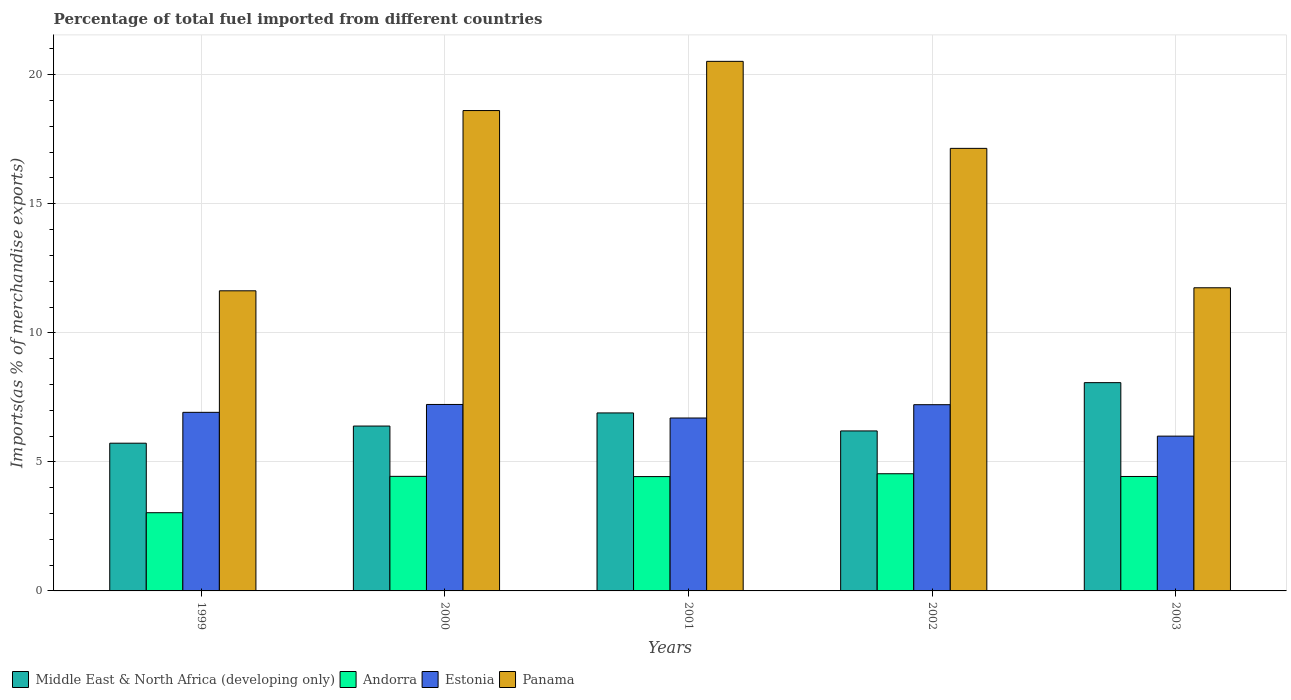How many groups of bars are there?
Your answer should be compact. 5. How many bars are there on the 4th tick from the left?
Make the answer very short. 4. How many bars are there on the 4th tick from the right?
Your answer should be very brief. 4. What is the label of the 4th group of bars from the left?
Keep it short and to the point. 2002. What is the percentage of imports to different countries in Estonia in 1999?
Your answer should be compact. 6.92. Across all years, what is the maximum percentage of imports to different countries in Panama?
Make the answer very short. 20.52. Across all years, what is the minimum percentage of imports to different countries in Estonia?
Make the answer very short. 6. In which year was the percentage of imports to different countries in Middle East & North Africa (developing only) maximum?
Keep it short and to the point. 2003. What is the total percentage of imports to different countries in Estonia in the graph?
Give a very brief answer. 34.06. What is the difference between the percentage of imports to different countries in Middle East & North Africa (developing only) in 1999 and that in 2000?
Provide a succinct answer. -0.66. What is the difference between the percentage of imports to different countries in Panama in 2001 and the percentage of imports to different countries in Estonia in 1999?
Ensure brevity in your answer.  13.6. What is the average percentage of imports to different countries in Panama per year?
Your answer should be very brief. 15.93. In the year 2001, what is the difference between the percentage of imports to different countries in Andorra and percentage of imports to different countries in Estonia?
Ensure brevity in your answer.  -2.27. What is the ratio of the percentage of imports to different countries in Andorra in 1999 to that in 2000?
Give a very brief answer. 0.68. Is the percentage of imports to different countries in Estonia in 2000 less than that in 2002?
Offer a terse response. No. Is the difference between the percentage of imports to different countries in Andorra in 1999 and 2000 greater than the difference between the percentage of imports to different countries in Estonia in 1999 and 2000?
Your answer should be compact. No. What is the difference between the highest and the second highest percentage of imports to different countries in Middle East & North Africa (developing only)?
Your answer should be very brief. 1.17. What is the difference between the highest and the lowest percentage of imports to different countries in Estonia?
Give a very brief answer. 1.23. In how many years, is the percentage of imports to different countries in Middle East & North Africa (developing only) greater than the average percentage of imports to different countries in Middle East & North Africa (developing only) taken over all years?
Your response must be concise. 2. Is the sum of the percentage of imports to different countries in Panama in 1999 and 2000 greater than the maximum percentage of imports to different countries in Andorra across all years?
Keep it short and to the point. Yes. What does the 2nd bar from the left in 2003 represents?
Give a very brief answer. Andorra. What does the 3rd bar from the right in 1999 represents?
Make the answer very short. Andorra. Is it the case that in every year, the sum of the percentage of imports to different countries in Middle East & North Africa (developing only) and percentage of imports to different countries in Andorra is greater than the percentage of imports to different countries in Estonia?
Offer a terse response. Yes. What is the difference between two consecutive major ticks on the Y-axis?
Provide a succinct answer. 5. Where does the legend appear in the graph?
Give a very brief answer. Bottom left. What is the title of the graph?
Your answer should be very brief. Percentage of total fuel imported from different countries. Does "Solomon Islands" appear as one of the legend labels in the graph?
Your answer should be compact. No. What is the label or title of the X-axis?
Provide a short and direct response. Years. What is the label or title of the Y-axis?
Provide a short and direct response. Imports(as % of merchandise exports). What is the Imports(as % of merchandise exports) of Middle East & North Africa (developing only) in 1999?
Give a very brief answer. 5.72. What is the Imports(as % of merchandise exports) of Andorra in 1999?
Provide a short and direct response. 3.03. What is the Imports(as % of merchandise exports) of Estonia in 1999?
Your answer should be compact. 6.92. What is the Imports(as % of merchandise exports) of Panama in 1999?
Your answer should be compact. 11.63. What is the Imports(as % of merchandise exports) of Middle East & North Africa (developing only) in 2000?
Provide a short and direct response. 6.39. What is the Imports(as % of merchandise exports) in Andorra in 2000?
Your response must be concise. 4.44. What is the Imports(as % of merchandise exports) of Estonia in 2000?
Provide a succinct answer. 7.22. What is the Imports(as % of merchandise exports) of Panama in 2000?
Offer a very short reply. 18.61. What is the Imports(as % of merchandise exports) in Middle East & North Africa (developing only) in 2001?
Offer a very short reply. 6.9. What is the Imports(as % of merchandise exports) of Andorra in 2001?
Your response must be concise. 4.43. What is the Imports(as % of merchandise exports) in Estonia in 2001?
Your answer should be very brief. 6.7. What is the Imports(as % of merchandise exports) in Panama in 2001?
Offer a very short reply. 20.52. What is the Imports(as % of merchandise exports) in Middle East & North Africa (developing only) in 2002?
Your answer should be very brief. 6.2. What is the Imports(as % of merchandise exports) of Andorra in 2002?
Your answer should be very brief. 4.54. What is the Imports(as % of merchandise exports) in Estonia in 2002?
Your response must be concise. 7.22. What is the Imports(as % of merchandise exports) of Panama in 2002?
Keep it short and to the point. 17.15. What is the Imports(as % of merchandise exports) in Middle East & North Africa (developing only) in 2003?
Give a very brief answer. 8.07. What is the Imports(as % of merchandise exports) of Andorra in 2003?
Your response must be concise. 4.43. What is the Imports(as % of merchandise exports) in Estonia in 2003?
Keep it short and to the point. 6. What is the Imports(as % of merchandise exports) of Panama in 2003?
Make the answer very short. 11.75. Across all years, what is the maximum Imports(as % of merchandise exports) of Middle East & North Africa (developing only)?
Offer a very short reply. 8.07. Across all years, what is the maximum Imports(as % of merchandise exports) of Andorra?
Keep it short and to the point. 4.54. Across all years, what is the maximum Imports(as % of merchandise exports) in Estonia?
Give a very brief answer. 7.22. Across all years, what is the maximum Imports(as % of merchandise exports) in Panama?
Make the answer very short. 20.52. Across all years, what is the minimum Imports(as % of merchandise exports) of Middle East & North Africa (developing only)?
Your answer should be compact. 5.72. Across all years, what is the minimum Imports(as % of merchandise exports) of Andorra?
Your response must be concise. 3.03. Across all years, what is the minimum Imports(as % of merchandise exports) of Estonia?
Provide a succinct answer. 6. Across all years, what is the minimum Imports(as % of merchandise exports) in Panama?
Ensure brevity in your answer.  11.63. What is the total Imports(as % of merchandise exports) in Middle East & North Africa (developing only) in the graph?
Keep it short and to the point. 33.28. What is the total Imports(as % of merchandise exports) of Andorra in the graph?
Give a very brief answer. 20.87. What is the total Imports(as % of merchandise exports) in Estonia in the graph?
Keep it short and to the point. 34.06. What is the total Imports(as % of merchandise exports) of Panama in the graph?
Provide a short and direct response. 79.65. What is the difference between the Imports(as % of merchandise exports) of Middle East & North Africa (developing only) in 1999 and that in 2000?
Give a very brief answer. -0.66. What is the difference between the Imports(as % of merchandise exports) of Andorra in 1999 and that in 2000?
Your answer should be very brief. -1.41. What is the difference between the Imports(as % of merchandise exports) in Estonia in 1999 and that in 2000?
Your answer should be very brief. -0.3. What is the difference between the Imports(as % of merchandise exports) of Panama in 1999 and that in 2000?
Your answer should be very brief. -6.98. What is the difference between the Imports(as % of merchandise exports) of Middle East & North Africa (developing only) in 1999 and that in 2001?
Offer a very short reply. -1.17. What is the difference between the Imports(as % of merchandise exports) of Andorra in 1999 and that in 2001?
Your answer should be compact. -1.4. What is the difference between the Imports(as % of merchandise exports) of Estonia in 1999 and that in 2001?
Keep it short and to the point. 0.22. What is the difference between the Imports(as % of merchandise exports) of Panama in 1999 and that in 2001?
Your answer should be compact. -8.89. What is the difference between the Imports(as % of merchandise exports) in Middle East & North Africa (developing only) in 1999 and that in 2002?
Ensure brevity in your answer.  -0.48. What is the difference between the Imports(as % of merchandise exports) in Andorra in 1999 and that in 2002?
Give a very brief answer. -1.51. What is the difference between the Imports(as % of merchandise exports) of Estonia in 1999 and that in 2002?
Make the answer very short. -0.3. What is the difference between the Imports(as % of merchandise exports) in Panama in 1999 and that in 2002?
Make the answer very short. -5.52. What is the difference between the Imports(as % of merchandise exports) of Middle East & North Africa (developing only) in 1999 and that in 2003?
Your answer should be compact. -2.35. What is the difference between the Imports(as % of merchandise exports) in Andorra in 1999 and that in 2003?
Keep it short and to the point. -1.4. What is the difference between the Imports(as % of merchandise exports) in Estonia in 1999 and that in 2003?
Give a very brief answer. 0.92. What is the difference between the Imports(as % of merchandise exports) of Panama in 1999 and that in 2003?
Offer a very short reply. -0.12. What is the difference between the Imports(as % of merchandise exports) of Middle East & North Africa (developing only) in 2000 and that in 2001?
Provide a succinct answer. -0.51. What is the difference between the Imports(as % of merchandise exports) in Andorra in 2000 and that in 2001?
Keep it short and to the point. 0.01. What is the difference between the Imports(as % of merchandise exports) in Estonia in 2000 and that in 2001?
Give a very brief answer. 0.52. What is the difference between the Imports(as % of merchandise exports) in Panama in 2000 and that in 2001?
Give a very brief answer. -1.91. What is the difference between the Imports(as % of merchandise exports) of Middle East & North Africa (developing only) in 2000 and that in 2002?
Make the answer very short. 0.19. What is the difference between the Imports(as % of merchandise exports) in Andorra in 2000 and that in 2002?
Provide a short and direct response. -0.1. What is the difference between the Imports(as % of merchandise exports) in Estonia in 2000 and that in 2002?
Give a very brief answer. 0.01. What is the difference between the Imports(as % of merchandise exports) in Panama in 2000 and that in 2002?
Keep it short and to the point. 1.46. What is the difference between the Imports(as % of merchandise exports) in Middle East & North Africa (developing only) in 2000 and that in 2003?
Make the answer very short. -1.68. What is the difference between the Imports(as % of merchandise exports) in Andorra in 2000 and that in 2003?
Provide a succinct answer. 0. What is the difference between the Imports(as % of merchandise exports) of Estonia in 2000 and that in 2003?
Your answer should be compact. 1.23. What is the difference between the Imports(as % of merchandise exports) of Panama in 2000 and that in 2003?
Provide a succinct answer. 6.87. What is the difference between the Imports(as % of merchandise exports) of Middle East & North Africa (developing only) in 2001 and that in 2002?
Your answer should be very brief. 0.7. What is the difference between the Imports(as % of merchandise exports) in Andorra in 2001 and that in 2002?
Your answer should be very brief. -0.11. What is the difference between the Imports(as % of merchandise exports) of Estonia in 2001 and that in 2002?
Give a very brief answer. -0.52. What is the difference between the Imports(as % of merchandise exports) of Panama in 2001 and that in 2002?
Your answer should be compact. 3.37. What is the difference between the Imports(as % of merchandise exports) of Middle East & North Africa (developing only) in 2001 and that in 2003?
Your answer should be very brief. -1.17. What is the difference between the Imports(as % of merchandise exports) of Andorra in 2001 and that in 2003?
Provide a short and direct response. -0. What is the difference between the Imports(as % of merchandise exports) of Estonia in 2001 and that in 2003?
Provide a succinct answer. 0.7. What is the difference between the Imports(as % of merchandise exports) of Panama in 2001 and that in 2003?
Keep it short and to the point. 8.77. What is the difference between the Imports(as % of merchandise exports) of Middle East & North Africa (developing only) in 2002 and that in 2003?
Provide a short and direct response. -1.87. What is the difference between the Imports(as % of merchandise exports) in Andorra in 2002 and that in 2003?
Your answer should be compact. 0.11. What is the difference between the Imports(as % of merchandise exports) of Estonia in 2002 and that in 2003?
Your response must be concise. 1.22. What is the difference between the Imports(as % of merchandise exports) in Panama in 2002 and that in 2003?
Provide a short and direct response. 5.4. What is the difference between the Imports(as % of merchandise exports) of Middle East & North Africa (developing only) in 1999 and the Imports(as % of merchandise exports) of Andorra in 2000?
Your response must be concise. 1.28. What is the difference between the Imports(as % of merchandise exports) in Middle East & North Africa (developing only) in 1999 and the Imports(as % of merchandise exports) in Estonia in 2000?
Your response must be concise. -1.5. What is the difference between the Imports(as % of merchandise exports) of Middle East & North Africa (developing only) in 1999 and the Imports(as % of merchandise exports) of Panama in 2000?
Make the answer very short. -12.89. What is the difference between the Imports(as % of merchandise exports) in Andorra in 1999 and the Imports(as % of merchandise exports) in Estonia in 2000?
Give a very brief answer. -4.19. What is the difference between the Imports(as % of merchandise exports) of Andorra in 1999 and the Imports(as % of merchandise exports) of Panama in 2000?
Provide a succinct answer. -15.58. What is the difference between the Imports(as % of merchandise exports) in Estonia in 1999 and the Imports(as % of merchandise exports) in Panama in 2000?
Your response must be concise. -11.69. What is the difference between the Imports(as % of merchandise exports) of Middle East & North Africa (developing only) in 1999 and the Imports(as % of merchandise exports) of Andorra in 2001?
Ensure brevity in your answer.  1.29. What is the difference between the Imports(as % of merchandise exports) in Middle East & North Africa (developing only) in 1999 and the Imports(as % of merchandise exports) in Estonia in 2001?
Provide a short and direct response. -0.98. What is the difference between the Imports(as % of merchandise exports) in Middle East & North Africa (developing only) in 1999 and the Imports(as % of merchandise exports) in Panama in 2001?
Make the answer very short. -14.79. What is the difference between the Imports(as % of merchandise exports) in Andorra in 1999 and the Imports(as % of merchandise exports) in Estonia in 2001?
Your answer should be very brief. -3.67. What is the difference between the Imports(as % of merchandise exports) in Andorra in 1999 and the Imports(as % of merchandise exports) in Panama in 2001?
Give a very brief answer. -17.49. What is the difference between the Imports(as % of merchandise exports) in Estonia in 1999 and the Imports(as % of merchandise exports) in Panama in 2001?
Ensure brevity in your answer.  -13.6. What is the difference between the Imports(as % of merchandise exports) in Middle East & North Africa (developing only) in 1999 and the Imports(as % of merchandise exports) in Andorra in 2002?
Offer a very short reply. 1.18. What is the difference between the Imports(as % of merchandise exports) in Middle East & North Africa (developing only) in 1999 and the Imports(as % of merchandise exports) in Estonia in 2002?
Make the answer very short. -1.49. What is the difference between the Imports(as % of merchandise exports) of Middle East & North Africa (developing only) in 1999 and the Imports(as % of merchandise exports) of Panama in 2002?
Offer a very short reply. -11.42. What is the difference between the Imports(as % of merchandise exports) of Andorra in 1999 and the Imports(as % of merchandise exports) of Estonia in 2002?
Offer a very short reply. -4.18. What is the difference between the Imports(as % of merchandise exports) in Andorra in 1999 and the Imports(as % of merchandise exports) in Panama in 2002?
Give a very brief answer. -14.12. What is the difference between the Imports(as % of merchandise exports) in Estonia in 1999 and the Imports(as % of merchandise exports) in Panama in 2002?
Ensure brevity in your answer.  -10.23. What is the difference between the Imports(as % of merchandise exports) in Middle East & North Africa (developing only) in 1999 and the Imports(as % of merchandise exports) in Andorra in 2003?
Keep it short and to the point. 1.29. What is the difference between the Imports(as % of merchandise exports) in Middle East & North Africa (developing only) in 1999 and the Imports(as % of merchandise exports) in Estonia in 2003?
Provide a succinct answer. -0.27. What is the difference between the Imports(as % of merchandise exports) in Middle East & North Africa (developing only) in 1999 and the Imports(as % of merchandise exports) in Panama in 2003?
Your response must be concise. -6.02. What is the difference between the Imports(as % of merchandise exports) in Andorra in 1999 and the Imports(as % of merchandise exports) in Estonia in 2003?
Provide a short and direct response. -2.97. What is the difference between the Imports(as % of merchandise exports) in Andorra in 1999 and the Imports(as % of merchandise exports) in Panama in 2003?
Keep it short and to the point. -8.72. What is the difference between the Imports(as % of merchandise exports) of Estonia in 1999 and the Imports(as % of merchandise exports) of Panama in 2003?
Ensure brevity in your answer.  -4.83. What is the difference between the Imports(as % of merchandise exports) of Middle East & North Africa (developing only) in 2000 and the Imports(as % of merchandise exports) of Andorra in 2001?
Offer a terse response. 1.96. What is the difference between the Imports(as % of merchandise exports) of Middle East & North Africa (developing only) in 2000 and the Imports(as % of merchandise exports) of Estonia in 2001?
Offer a terse response. -0.31. What is the difference between the Imports(as % of merchandise exports) in Middle East & North Africa (developing only) in 2000 and the Imports(as % of merchandise exports) in Panama in 2001?
Keep it short and to the point. -14.13. What is the difference between the Imports(as % of merchandise exports) in Andorra in 2000 and the Imports(as % of merchandise exports) in Estonia in 2001?
Your answer should be very brief. -2.26. What is the difference between the Imports(as % of merchandise exports) of Andorra in 2000 and the Imports(as % of merchandise exports) of Panama in 2001?
Provide a short and direct response. -16.08. What is the difference between the Imports(as % of merchandise exports) in Estonia in 2000 and the Imports(as % of merchandise exports) in Panama in 2001?
Offer a terse response. -13.29. What is the difference between the Imports(as % of merchandise exports) in Middle East & North Africa (developing only) in 2000 and the Imports(as % of merchandise exports) in Andorra in 2002?
Offer a terse response. 1.85. What is the difference between the Imports(as % of merchandise exports) of Middle East & North Africa (developing only) in 2000 and the Imports(as % of merchandise exports) of Estonia in 2002?
Your answer should be very brief. -0.83. What is the difference between the Imports(as % of merchandise exports) in Middle East & North Africa (developing only) in 2000 and the Imports(as % of merchandise exports) in Panama in 2002?
Keep it short and to the point. -10.76. What is the difference between the Imports(as % of merchandise exports) in Andorra in 2000 and the Imports(as % of merchandise exports) in Estonia in 2002?
Keep it short and to the point. -2.78. What is the difference between the Imports(as % of merchandise exports) of Andorra in 2000 and the Imports(as % of merchandise exports) of Panama in 2002?
Offer a terse response. -12.71. What is the difference between the Imports(as % of merchandise exports) of Estonia in 2000 and the Imports(as % of merchandise exports) of Panama in 2002?
Keep it short and to the point. -9.92. What is the difference between the Imports(as % of merchandise exports) in Middle East & North Africa (developing only) in 2000 and the Imports(as % of merchandise exports) in Andorra in 2003?
Provide a short and direct response. 1.95. What is the difference between the Imports(as % of merchandise exports) of Middle East & North Africa (developing only) in 2000 and the Imports(as % of merchandise exports) of Estonia in 2003?
Offer a very short reply. 0.39. What is the difference between the Imports(as % of merchandise exports) in Middle East & North Africa (developing only) in 2000 and the Imports(as % of merchandise exports) in Panama in 2003?
Offer a terse response. -5.36. What is the difference between the Imports(as % of merchandise exports) in Andorra in 2000 and the Imports(as % of merchandise exports) in Estonia in 2003?
Provide a succinct answer. -1.56. What is the difference between the Imports(as % of merchandise exports) in Andorra in 2000 and the Imports(as % of merchandise exports) in Panama in 2003?
Give a very brief answer. -7.31. What is the difference between the Imports(as % of merchandise exports) of Estonia in 2000 and the Imports(as % of merchandise exports) of Panama in 2003?
Your answer should be very brief. -4.52. What is the difference between the Imports(as % of merchandise exports) of Middle East & North Africa (developing only) in 2001 and the Imports(as % of merchandise exports) of Andorra in 2002?
Your answer should be compact. 2.36. What is the difference between the Imports(as % of merchandise exports) of Middle East & North Africa (developing only) in 2001 and the Imports(as % of merchandise exports) of Estonia in 2002?
Make the answer very short. -0.32. What is the difference between the Imports(as % of merchandise exports) in Middle East & North Africa (developing only) in 2001 and the Imports(as % of merchandise exports) in Panama in 2002?
Your answer should be compact. -10.25. What is the difference between the Imports(as % of merchandise exports) of Andorra in 2001 and the Imports(as % of merchandise exports) of Estonia in 2002?
Keep it short and to the point. -2.79. What is the difference between the Imports(as % of merchandise exports) in Andorra in 2001 and the Imports(as % of merchandise exports) in Panama in 2002?
Offer a very short reply. -12.72. What is the difference between the Imports(as % of merchandise exports) in Estonia in 2001 and the Imports(as % of merchandise exports) in Panama in 2002?
Give a very brief answer. -10.45. What is the difference between the Imports(as % of merchandise exports) in Middle East & North Africa (developing only) in 2001 and the Imports(as % of merchandise exports) in Andorra in 2003?
Provide a succinct answer. 2.46. What is the difference between the Imports(as % of merchandise exports) in Middle East & North Africa (developing only) in 2001 and the Imports(as % of merchandise exports) in Estonia in 2003?
Ensure brevity in your answer.  0.9. What is the difference between the Imports(as % of merchandise exports) of Middle East & North Africa (developing only) in 2001 and the Imports(as % of merchandise exports) of Panama in 2003?
Provide a short and direct response. -4.85. What is the difference between the Imports(as % of merchandise exports) of Andorra in 2001 and the Imports(as % of merchandise exports) of Estonia in 2003?
Ensure brevity in your answer.  -1.57. What is the difference between the Imports(as % of merchandise exports) in Andorra in 2001 and the Imports(as % of merchandise exports) in Panama in 2003?
Keep it short and to the point. -7.32. What is the difference between the Imports(as % of merchandise exports) of Estonia in 2001 and the Imports(as % of merchandise exports) of Panama in 2003?
Keep it short and to the point. -5.05. What is the difference between the Imports(as % of merchandise exports) in Middle East & North Africa (developing only) in 2002 and the Imports(as % of merchandise exports) in Andorra in 2003?
Keep it short and to the point. 1.76. What is the difference between the Imports(as % of merchandise exports) in Middle East & North Africa (developing only) in 2002 and the Imports(as % of merchandise exports) in Estonia in 2003?
Your answer should be compact. 0.2. What is the difference between the Imports(as % of merchandise exports) in Middle East & North Africa (developing only) in 2002 and the Imports(as % of merchandise exports) in Panama in 2003?
Make the answer very short. -5.55. What is the difference between the Imports(as % of merchandise exports) in Andorra in 2002 and the Imports(as % of merchandise exports) in Estonia in 2003?
Ensure brevity in your answer.  -1.46. What is the difference between the Imports(as % of merchandise exports) of Andorra in 2002 and the Imports(as % of merchandise exports) of Panama in 2003?
Keep it short and to the point. -7.21. What is the difference between the Imports(as % of merchandise exports) in Estonia in 2002 and the Imports(as % of merchandise exports) in Panama in 2003?
Give a very brief answer. -4.53. What is the average Imports(as % of merchandise exports) in Middle East & North Africa (developing only) per year?
Ensure brevity in your answer.  6.66. What is the average Imports(as % of merchandise exports) of Andorra per year?
Offer a terse response. 4.17. What is the average Imports(as % of merchandise exports) in Estonia per year?
Offer a very short reply. 6.81. What is the average Imports(as % of merchandise exports) in Panama per year?
Give a very brief answer. 15.93. In the year 1999, what is the difference between the Imports(as % of merchandise exports) of Middle East & North Africa (developing only) and Imports(as % of merchandise exports) of Andorra?
Make the answer very short. 2.69. In the year 1999, what is the difference between the Imports(as % of merchandise exports) in Middle East & North Africa (developing only) and Imports(as % of merchandise exports) in Estonia?
Offer a very short reply. -1.2. In the year 1999, what is the difference between the Imports(as % of merchandise exports) in Middle East & North Africa (developing only) and Imports(as % of merchandise exports) in Panama?
Offer a very short reply. -5.9. In the year 1999, what is the difference between the Imports(as % of merchandise exports) in Andorra and Imports(as % of merchandise exports) in Estonia?
Your answer should be compact. -3.89. In the year 1999, what is the difference between the Imports(as % of merchandise exports) of Andorra and Imports(as % of merchandise exports) of Panama?
Make the answer very short. -8.6. In the year 1999, what is the difference between the Imports(as % of merchandise exports) in Estonia and Imports(as % of merchandise exports) in Panama?
Keep it short and to the point. -4.71. In the year 2000, what is the difference between the Imports(as % of merchandise exports) of Middle East & North Africa (developing only) and Imports(as % of merchandise exports) of Andorra?
Give a very brief answer. 1.95. In the year 2000, what is the difference between the Imports(as % of merchandise exports) in Middle East & North Africa (developing only) and Imports(as % of merchandise exports) in Estonia?
Offer a very short reply. -0.84. In the year 2000, what is the difference between the Imports(as % of merchandise exports) in Middle East & North Africa (developing only) and Imports(as % of merchandise exports) in Panama?
Make the answer very short. -12.22. In the year 2000, what is the difference between the Imports(as % of merchandise exports) in Andorra and Imports(as % of merchandise exports) in Estonia?
Ensure brevity in your answer.  -2.79. In the year 2000, what is the difference between the Imports(as % of merchandise exports) of Andorra and Imports(as % of merchandise exports) of Panama?
Ensure brevity in your answer.  -14.17. In the year 2000, what is the difference between the Imports(as % of merchandise exports) in Estonia and Imports(as % of merchandise exports) in Panama?
Give a very brief answer. -11.39. In the year 2001, what is the difference between the Imports(as % of merchandise exports) in Middle East & North Africa (developing only) and Imports(as % of merchandise exports) in Andorra?
Provide a succinct answer. 2.47. In the year 2001, what is the difference between the Imports(as % of merchandise exports) of Middle East & North Africa (developing only) and Imports(as % of merchandise exports) of Estonia?
Provide a short and direct response. 0.2. In the year 2001, what is the difference between the Imports(as % of merchandise exports) of Middle East & North Africa (developing only) and Imports(as % of merchandise exports) of Panama?
Your answer should be compact. -13.62. In the year 2001, what is the difference between the Imports(as % of merchandise exports) in Andorra and Imports(as % of merchandise exports) in Estonia?
Keep it short and to the point. -2.27. In the year 2001, what is the difference between the Imports(as % of merchandise exports) of Andorra and Imports(as % of merchandise exports) of Panama?
Provide a short and direct response. -16.09. In the year 2001, what is the difference between the Imports(as % of merchandise exports) in Estonia and Imports(as % of merchandise exports) in Panama?
Offer a very short reply. -13.82. In the year 2002, what is the difference between the Imports(as % of merchandise exports) of Middle East & North Africa (developing only) and Imports(as % of merchandise exports) of Andorra?
Ensure brevity in your answer.  1.66. In the year 2002, what is the difference between the Imports(as % of merchandise exports) in Middle East & North Africa (developing only) and Imports(as % of merchandise exports) in Estonia?
Your answer should be compact. -1.02. In the year 2002, what is the difference between the Imports(as % of merchandise exports) of Middle East & North Africa (developing only) and Imports(as % of merchandise exports) of Panama?
Your response must be concise. -10.95. In the year 2002, what is the difference between the Imports(as % of merchandise exports) in Andorra and Imports(as % of merchandise exports) in Estonia?
Give a very brief answer. -2.68. In the year 2002, what is the difference between the Imports(as % of merchandise exports) in Andorra and Imports(as % of merchandise exports) in Panama?
Make the answer very short. -12.61. In the year 2002, what is the difference between the Imports(as % of merchandise exports) in Estonia and Imports(as % of merchandise exports) in Panama?
Keep it short and to the point. -9.93. In the year 2003, what is the difference between the Imports(as % of merchandise exports) of Middle East & North Africa (developing only) and Imports(as % of merchandise exports) of Andorra?
Offer a very short reply. 3.63. In the year 2003, what is the difference between the Imports(as % of merchandise exports) in Middle East & North Africa (developing only) and Imports(as % of merchandise exports) in Estonia?
Ensure brevity in your answer.  2.07. In the year 2003, what is the difference between the Imports(as % of merchandise exports) of Middle East & North Africa (developing only) and Imports(as % of merchandise exports) of Panama?
Offer a very short reply. -3.68. In the year 2003, what is the difference between the Imports(as % of merchandise exports) of Andorra and Imports(as % of merchandise exports) of Estonia?
Your answer should be very brief. -1.56. In the year 2003, what is the difference between the Imports(as % of merchandise exports) in Andorra and Imports(as % of merchandise exports) in Panama?
Offer a terse response. -7.31. In the year 2003, what is the difference between the Imports(as % of merchandise exports) in Estonia and Imports(as % of merchandise exports) in Panama?
Make the answer very short. -5.75. What is the ratio of the Imports(as % of merchandise exports) of Middle East & North Africa (developing only) in 1999 to that in 2000?
Your response must be concise. 0.9. What is the ratio of the Imports(as % of merchandise exports) of Andorra in 1999 to that in 2000?
Your answer should be compact. 0.68. What is the ratio of the Imports(as % of merchandise exports) in Estonia in 1999 to that in 2000?
Ensure brevity in your answer.  0.96. What is the ratio of the Imports(as % of merchandise exports) in Panama in 1999 to that in 2000?
Your answer should be very brief. 0.62. What is the ratio of the Imports(as % of merchandise exports) of Middle East & North Africa (developing only) in 1999 to that in 2001?
Your answer should be very brief. 0.83. What is the ratio of the Imports(as % of merchandise exports) in Andorra in 1999 to that in 2001?
Make the answer very short. 0.68. What is the ratio of the Imports(as % of merchandise exports) in Estonia in 1999 to that in 2001?
Make the answer very short. 1.03. What is the ratio of the Imports(as % of merchandise exports) in Panama in 1999 to that in 2001?
Ensure brevity in your answer.  0.57. What is the ratio of the Imports(as % of merchandise exports) of Middle East & North Africa (developing only) in 1999 to that in 2002?
Keep it short and to the point. 0.92. What is the ratio of the Imports(as % of merchandise exports) in Andorra in 1999 to that in 2002?
Offer a terse response. 0.67. What is the ratio of the Imports(as % of merchandise exports) of Estonia in 1999 to that in 2002?
Your answer should be very brief. 0.96. What is the ratio of the Imports(as % of merchandise exports) of Panama in 1999 to that in 2002?
Give a very brief answer. 0.68. What is the ratio of the Imports(as % of merchandise exports) of Middle East & North Africa (developing only) in 1999 to that in 2003?
Offer a very short reply. 0.71. What is the ratio of the Imports(as % of merchandise exports) of Andorra in 1999 to that in 2003?
Offer a very short reply. 0.68. What is the ratio of the Imports(as % of merchandise exports) of Estonia in 1999 to that in 2003?
Offer a terse response. 1.15. What is the ratio of the Imports(as % of merchandise exports) in Panama in 1999 to that in 2003?
Ensure brevity in your answer.  0.99. What is the ratio of the Imports(as % of merchandise exports) of Middle East & North Africa (developing only) in 2000 to that in 2001?
Offer a very short reply. 0.93. What is the ratio of the Imports(as % of merchandise exports) of Andorra in 2000 to that in 2001?
Make the answer very short. 1. What is the ratio of the Imports(as % of merchandise exports) in Estonia in 2000 to that in 2001?
Keep it short and to the point. 1.08. What is the ratio of the Imports(as % of merchandise exports) of Panama in 2000 to that in 2001?
Provide a short and direct response. 0.91. What is the ratio of the Imports(as % of merchandise exports) in Middle East & North Africa (developing only) in 2000 to that in 2002?
Your answer should be very brief. 1.03. What is the ratio of the Imports(as % of merchandise exports) in Andorra in 2000 to that in 2002?
Your response must be concise. 0.98. What is the ratio of the Imports(as % of merchandise exports) in Panama in 2000 to that in 2002?
Provide a succinct answer. 1.09. What is the ratio of the Imports(as % of merchandise exports) of Middle East & North Africa (developing only) in 2000 to that in 2003?
Your answer should be compact. 0.79. What is the ratio of the Imports(as % of merchandise exports) in Andorra in 2000 to that in 2003?
Ensure brevity in your answer.  1. What is the ratio of the Imports(as % of merchandise exports) in Estonia in 2000 to that in 2003?
Give a very brief answer. 1.2. What is the ratio of the Imports(as % of merchandise exports) of Panama in 2000 to that in 2003?
Provide a succinct answer. 1.58. What is the ratio of the Imports(as % of merchandise exports) of Middle East & North Africa (developing only) in 2001 to that in 2002?
Provide a short and direct response. 1.11. What is the ratio of the Imports(as % of merchandise exports) in Andorra in 2001 to that in 2002?
Ensure brevity in your answer.  0.98. What is the ratio of the Imports(as % of merchandise exports) in Estonia in 2001 to that in 2002?
Ensure brevity in your answer.  0.93. What is the ratio of the Imports(as % of merchandise exports) in Panama in 2001 to that in 2002?
Your response must be concise. 1.2. What is the ratio of the Imports(as % of merchandise exports) in Middle East & North Africa (developing only) in 2001 to that in 2003?
Ensure brevity in your answer.  0.85. What is the ratio of the Imports(as % of merchandise exports) in Estonia in 2001 to that in 2003?
Offer a very short reply. 1.12. What is the ratio of the Imports(as % of merchandise exports) of Panama in 2001 to that in 2003?
Offer a very short reply. 1.75. What is the ratio of the Imports(as % of merchandise exports) of Middle East & North Africa (developing only) in 2002 to that in 2003?
Keep it short and to the point. 0.77. What is the ratio of the Imports(as % of merchandise exports) of Andorra in 2002 to that in 2003?
Your answer should be very brief. 1.02. What is the ratio of the Imports(as % of merchandise exports) of Estonia in 2002 to that in 2003?
Your answer should be very brief. 1.2. What is the ratio of the Imports(as % of merchandise exports) in Panama in 2002 to that in 2003?
Your answer should be very brief. 1.46. What is the difference between the highest and the second highest Imports(as % of merchandise exports) of Middle East & North Africa (developing only)?
Offer a very short reply. 1.17. What is the difference between the highest and the second highest Imports(as % of merchandise exports) of Andorra?
Provide a succinct answer. 0.1. What is the difference between the highest and the second highest Imports(as % of merchandise exports) of Estonia?
Your response must be concise. 0.01. What is the difference between the highest and the second highest Imports(as % of merchandise exports) of Panama?
Offer a terse response. 1.91. What is the difference between the highest and the lowest Imports(as % of merchandise exports) of Middle East & North Africa (developing only)?
Keep it short and to the point. 2.35. What is the difference between the highest and the lowest Imports(as % of merchandise exports) of Andorra?
Ensure brevity in your answer.  1.51. What is the difference between the highest and the lowest Imports(as % of merchandise exports) in Estonia?
Your answer should be compact. 1.23. What is the difference between the highest and the lowest Imports(as % of merchandise exports) of Panama?
Provide a short and direct response. 8.89. 